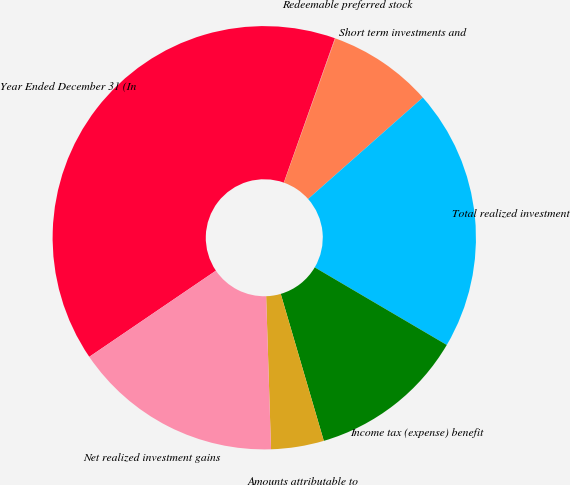Convert chart to OTSL. <chart><loc_0><loc_0><loc_500><loc_500><pie_chart><fcel>Year Ended December 31 (In<fcel>Redeemable preferred stock<fcel>Short term investments and<fcel>Total realized investment<fcel>Income tax (expense) benefit<fcel>Amounts attributable to<fcel>Net realized investment gains<nl><fcel>39.93%<fcel>0.04%<fcel>8.02%<fcel>19.98%<fcel>12.01%<fcel>4.03%<fcel>16.0%<nl></chart> 